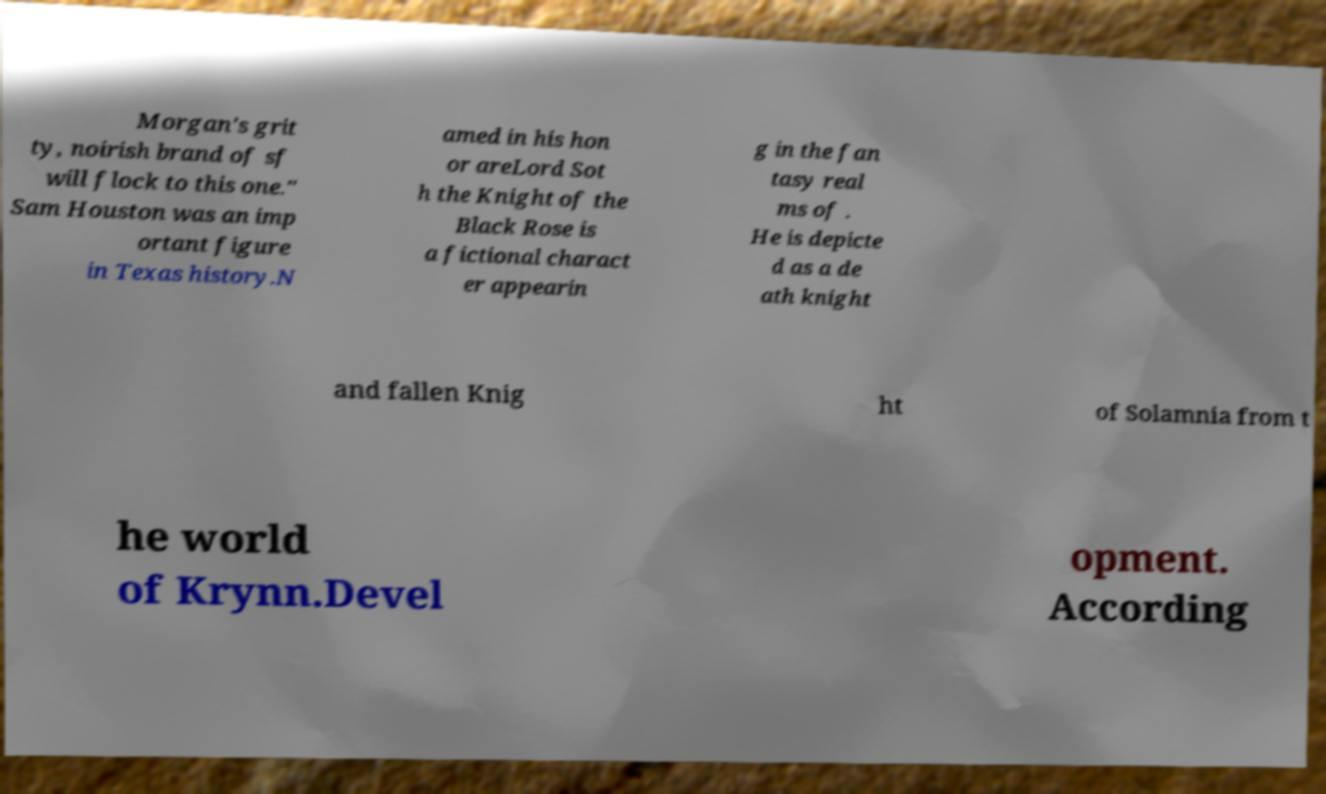Please identify and transcribe the text found in this image. Morgan's grit ty, noirish brand of sf will flock to this one." Sam Houston was an imp ortant figure in Texas history.N amed in his hon or areLord Sot h the Knight of the Black Rose is a fictional charact er appearin g in the fan tasy real ms of . He is depicte d as a de ath knight and fallen Knig ht of Solamnia from t he world of Krynn.Devel opment. According 